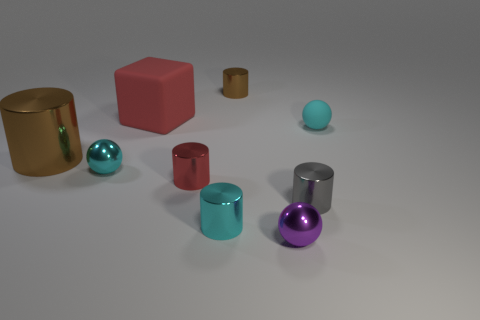There is a sphere that is in front of the big metallic cylinder and right of the large red thing; what color is it?
Ensure brevity in your answer.  Purple. There is a big object in front of the matte ball; what number of small gray metal cylinders are behind it?
Ensure brevity in your answer.  0. Is the large brown thing the same shape as the cyan matte object?
Provide a short and direct response. No. Do the tiny red thing and the matte thing left of the gray cylinder have the same shape?
Provide a short and direct response. No. What color is the tiny metallic cylinder that is to the right of the tiny thing behind the cyan sphere right of the purple thing?
Your response must be concise. Gray. There is a brown metal thing to the left of the big red cube; is it the same shape as the purple object?
Your answer should be compact. No. What is the shape of the metallic object behind the tiny cyan thing that is to the right of the metallic object behind the big brown metal cylinder?
Provide a short and direct response. Cylinder. There is a small matte sphere; is its color the same as the tiny sphere to the left of the small brown shiny cylinder?
Your answer should be compact. Yes. What number of metal things are there?
Keep it short and to the point. 7. What number of things are either yellow metallic cylinders or small objects?
Provide a short and direct response. 7. 